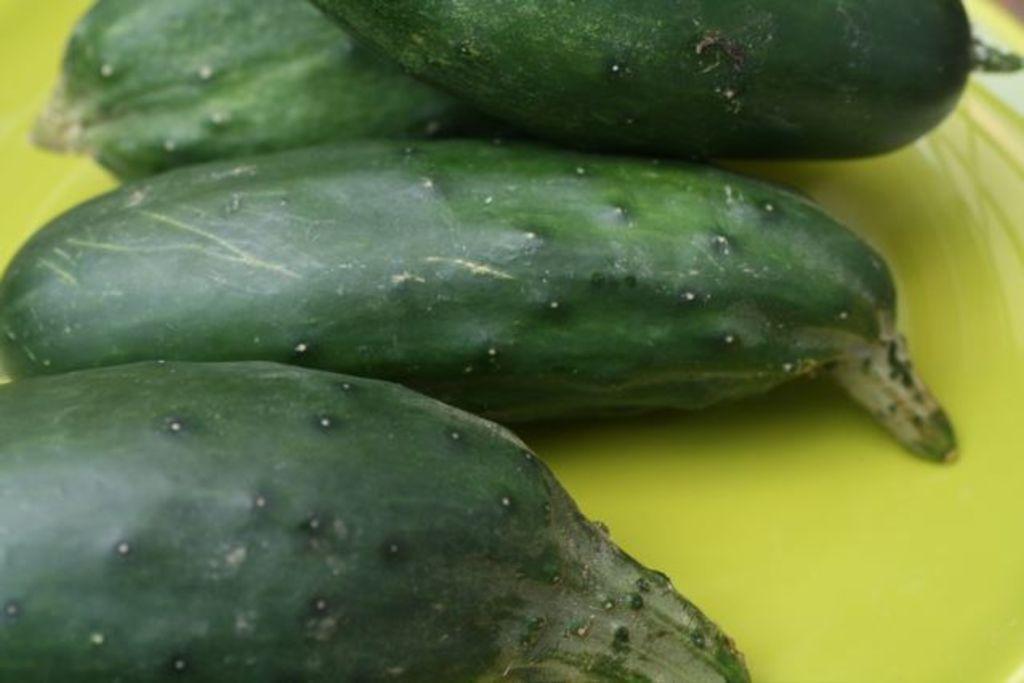Describe this image in one or two sentences. As we can see in the image, there are green colored cucumbers. 